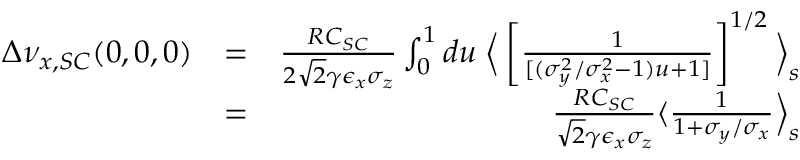Convert formula to latex. <formula><loc_0><loc_0><loc_500><loc_500>\begin{array} { r l r } { \Delta \nu _ { x , S C } ( 0 , 0 , 0 ) } & { = } & { \frac { R C _ { S C } } { 2 \sqrt { 2 } \gamma \epsilon _ { x } \sigma _ { z } } \int _ { 0 } ^ { 1 } d u \, \Big \langle \left [ \frac { 1 } { [ ( \sigma _ { y } ^ { 2 } / \sigma _ { x } ^ { 2 } - 1 ) u + 1 ] } \right ] ^ { 1 / 2 } \Big \rangle _ { s } } \\ & { = } & { \frac { R C _ { S C } } { \sqrt { 2 } \gamma \epsilon _ { x } \sigma _ { z } } \langle \frac { 1 } { 1 + \sigma _ { y } / \sigma _ { x } } \Big \rangle _ { s } } \end{array}</formula> 